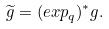<formula> <loc_0><loc_0><loc_500><loc_500>\widetilde { g } = ( e x p _ { q } ) ^ { * } { g } .</formula> 